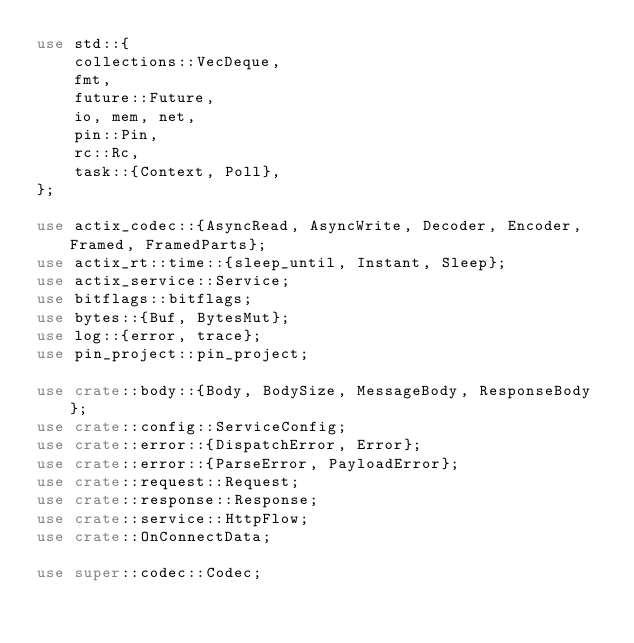Convert code to text. <code><loc_0><loc_0><loc_500><loc_500><_Rust_>use std::{
    collections::VecDeque,
    fmt,
    future::Future,
    io, mem, net,
    pin::Pin,
    rc::Rc,
    task::{Context, Poll},
};

use actix_codec::{AsyncRead, AsyncWrite, Decoder, Encoder, Framed, FramedParts};
use actix_rt::time::{sleep_until, Instant, Sleep};
use actix_service::Service;
use bitflags::bitflags;
use bytes::{Buf, BytesMut};
use log::{error, trace};
use pin_project::pin_project;

use crate::body::{Body, BodySize, MessageBody, ResponseBody};
use crate::config::ServiceConfig;
use crate::error::{DispatchError, Error};
use crate::error::{ParseError, PayloadError};
use crate::request::Request;
use crate::response::Response;
use crate::service::HttpFlow;
use crate::OnConnectData;

use super::codec::Codec;</code> 